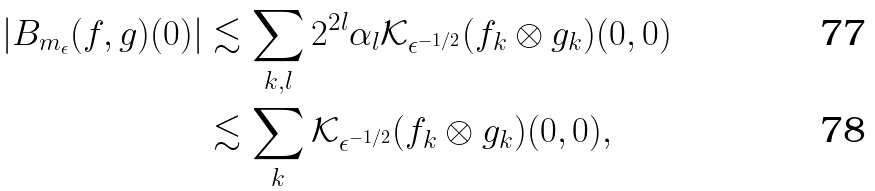<formula> <loc_0><loc_0><loc_500><loc_500>\left | B _ { m _ { \epsilon } } ( f , g ) ( 0 ) \right | & \lesssim \sum _ { k , l } 2 ^ { 2 l } \alpha _ { l } { \mathcal { K } } _ { \epsilon ^ { - 1 / 2 } } ( f _ { k } \otimes g _ { k } ) ( 0 , 0 ) \\ & \lesssim \sum _ { k } { \mathcal { K } } _ { \epsilon ^ { - 1 / 2 } } ( f _ { k } \otimes g _ { k } ) ( 0 , 0 ) ,</formula> 